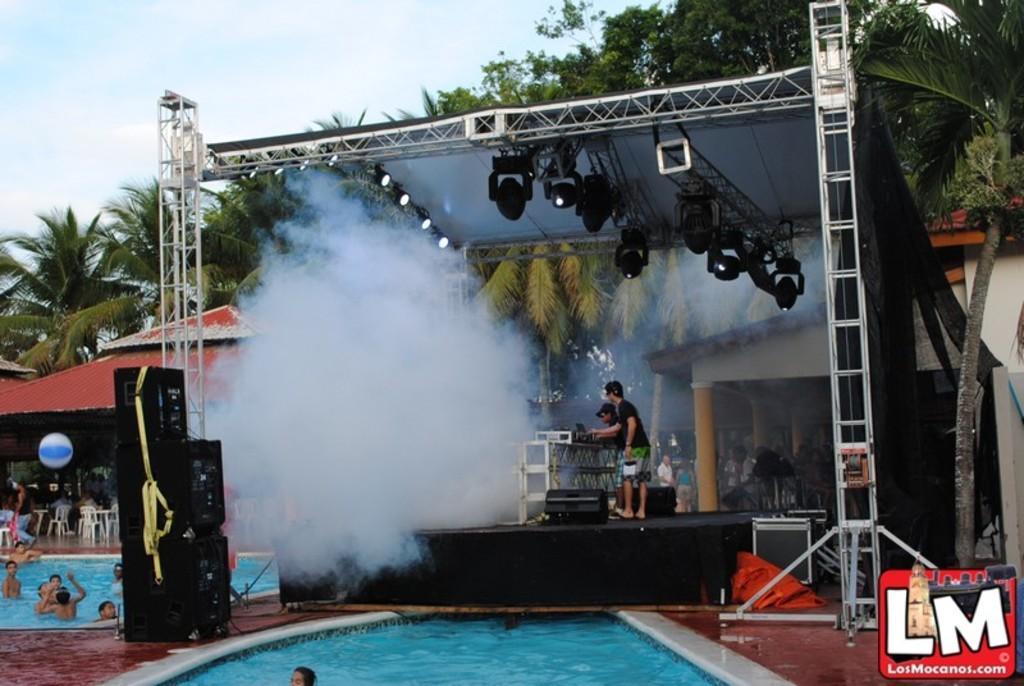Could you give a brief overview of what you see in this image? In the picture I can see stage lights, people among them some are standing on the stage and some are in the water. In the background I can see the sky, trees, roof, house, white smoke and some other objects. On the bottom right side of the image I can see a logo on the image. 